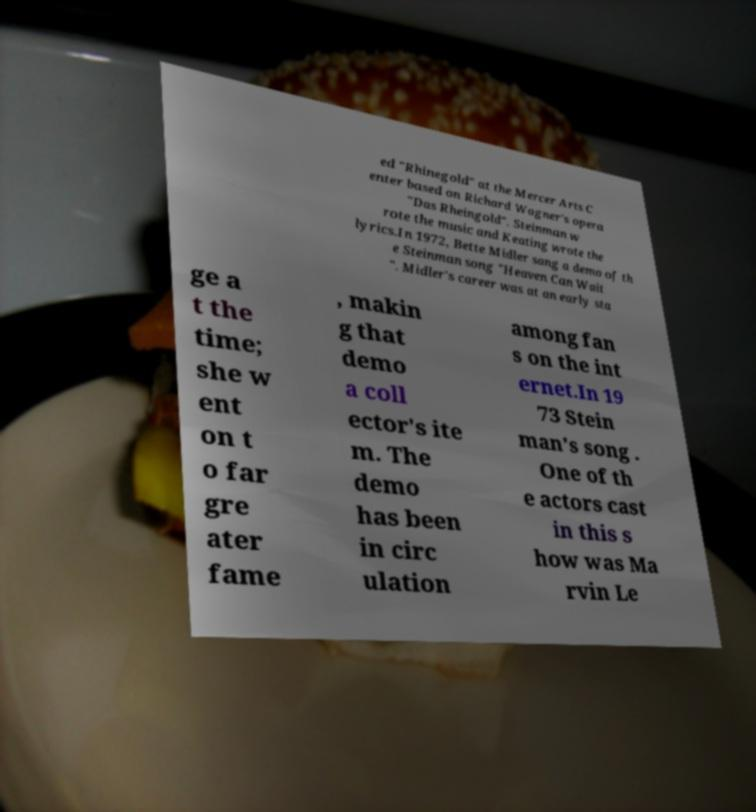Please identify and transcribe the text found in this image. ed "Rhinegold" at the Mercer Arts C enter based on Richard Wagner's opera "Das Rheingold". Steinman w rote the music and Keating wrote the lyrics.In 1972, Bette Midler sang a demo of th e Steinman song "Heaven Can Wait ". Midler's career was at an early sta ge a t the time; she w ent on t o far gre ater fame , makin g that demo a coll ector's ite m. The demo has been in circ ulation among fan s on the int ernet.In 19 73 Stein man's song . One of th e actors cast in this s how was Ma rvin Le 